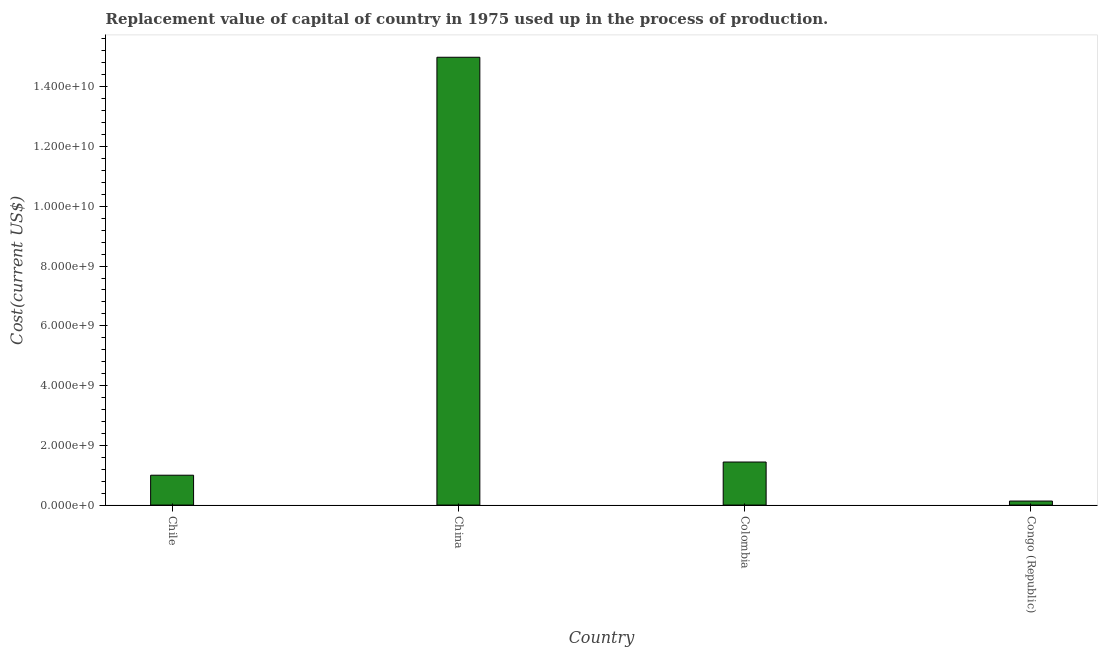What is the title of the graph?
Keep it short and to the point. Replacement value of capital of country in 1975 used up in the process of production. What is the label or title of the X-axis?
Keep it short and to the point. Country. What is the label or title of the Y-axis?
Make the answer very short. Cost(current US$). What is the consumption of fixed capital in China?
Offer a very short reply. 1.50e+1. Across all countries, what is the maximum consumption of fixed capital?
Offer a terse response. 1.50e+1. Across all countries, what is the minimum consumption of fixed capital?
Provide a short and direct response. 1.34e+08. In which country was the consumption of fixed capital maximum?
Make the answer very short. China. In which country was the consumption of fixed capital minimum?
Your answer should be very brief. Congo (Republic). What is the sum of the consumption of fixed capital?
Provide a succinct answer. 1.76e+1. What is the difference between the consumption of fixed capital in China and Congo (Republic)?
Provide a succinct answer. 1.49e+1. What is the average consumption of fixed capital per country?
Keep it short and to the point. 4.39e+09. What is the median consumption of fixed capital?
Give a very brief answer. 1.22e+09. What is the ratio of the consumption of fixed capital in China to that in Congo (Republic)?
Provide a short and direct response. 111.64. What is the difference between the highest and the second highest consumption of fixed capital?
Give a very brief answer. 1.35e+1. Is the sum of the consumption of fixed capital in China and Colombia greater than the maximum consumption of fixed capital across all countries?
Provide a succinct answer. Yes. What is the difference between the highest and the lowest consumption of fixed capital?
Ensure brevity in your answer.  1.49e+1. In how many countries, is the consumption of fixed capital greater than the average consumption of fixed capital taken over all countries?
Your answer should be very brief. 1. How many countries are there in the graph?
Offer a very short reply. 4. Are the values on the major ticks of Y-axis written in scientific E-notation?
Offer a terse response. Yes. What is the Cost(current US$) of Chile?
Give a very brief answer. 9.99e+08. What is the Cost(current US$) in China?
Offer a very short reply. 1.50e+1. What is the Cost(current US$) of Colombia?
Your answer should be compact. 1.44e+09. What is the Cost(current US$) in Congo (Republic)?
Your answer should be very brief. 1.34e+08. What is the difference between the Cost(current US$) in Chile and China?
Your answer should be compact. -1.40e+1. What is the difference between the Cost(current US$) in Chile and Colombia?
Offer a terse response. -4.41e+08. What is the difference between the Cost(current US$) in Chile and Congo (Republic)?
Provide a short and direct response. 8.65e+08. What is the difference between the Cost(current US$) in China and Colombia?
Make the answer very short. 1.35e+1. What is the difference between the Cost(current US$) in China and Congo (Republic)?
Provide a short and direct response. 1.49e+1. What is the difference between the Cost(current US$) in Colombia and Congo (Republic)?
Make the answer very short. 1.31e+09. What is the ratio of the Cost(current US$) in Chile to that in China?
Offer a very short reply. 0.07. What is the ratio of the Cost(current US$) in Chile to that in Colombia?
Your answer should be compact. 0.69. What is the ratio of the Cost(current US$) in Chile to that in Congo (Republic)?
Your response must be concise. 7.45. What is the ratio of the Cost(current US$) in China to that in Colombia?
Make the answer very short. 10.4. What is the ratio of the Cost(current US$) in China to that in Congo (Republic)?
Provide a short and direct response. 111.64. What is the ratio of the Cost(current US$) in Colombia to that in Congo (Republic)?
Your answer should be very brief. 10.73. 